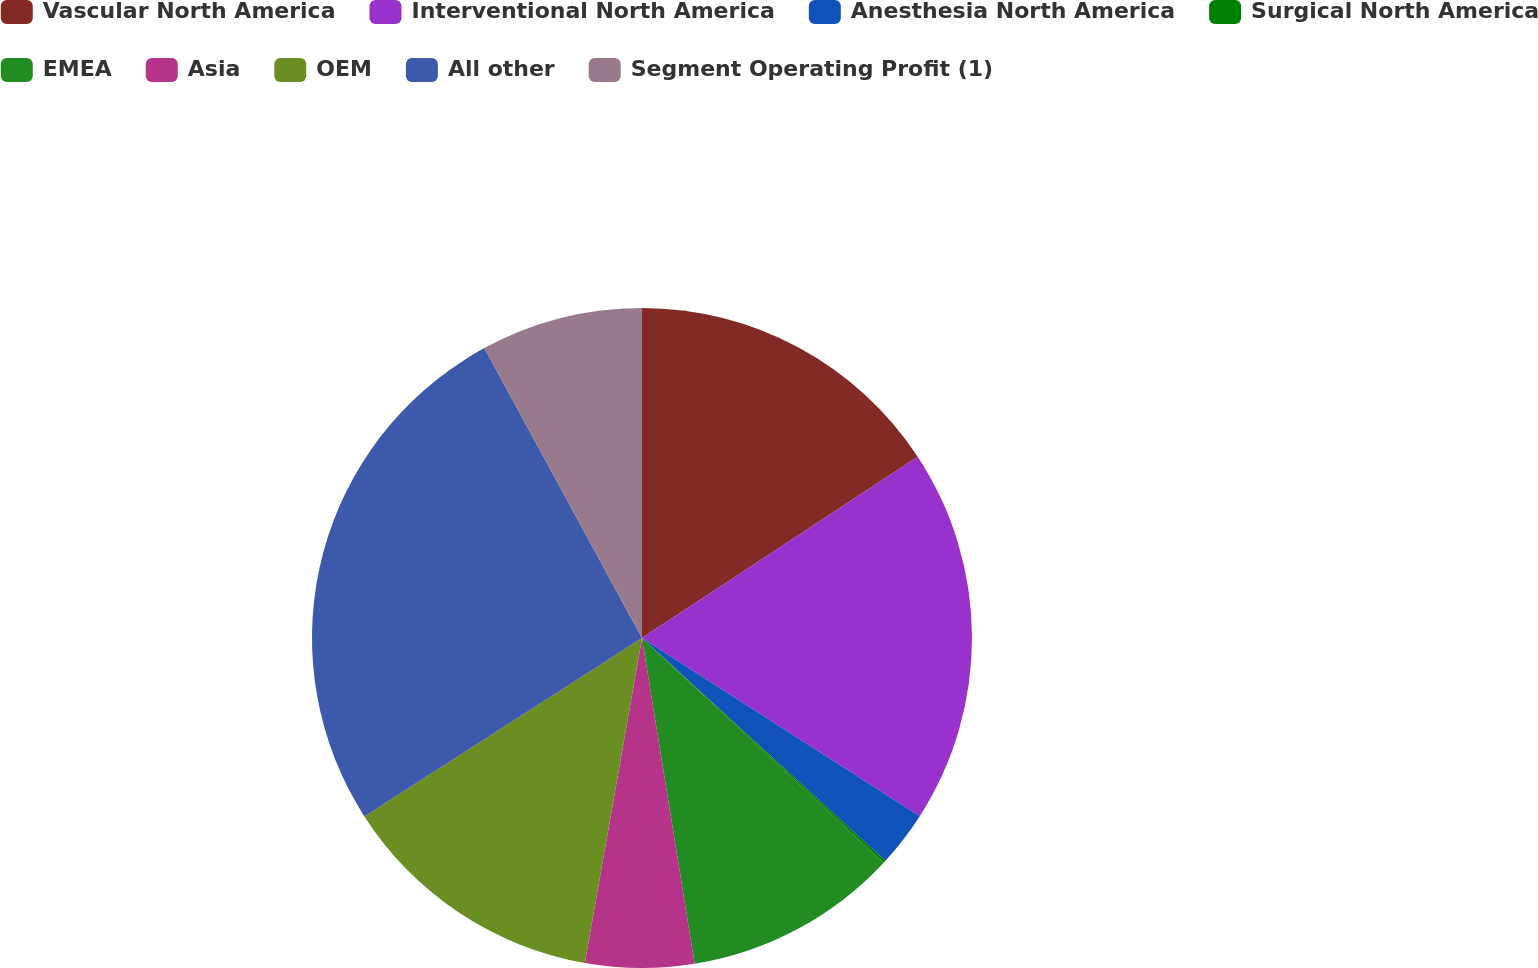Convert chart. <chart><loc_0><loc_0><loc_500><loc_500><pie_chart><fcel>Vascular North America<fcel>Interventional North America<fcel>Anesthesia North America<fcel>Surgical North America<fcel>EMEA<fcel>Asia<fcel>OEM<fcel>All other<fcel>Segment Operating Profit (1)<nl><fcel>15.74%<fcel>18.34%<fcel>2.72%<fcel>0.12%<fcel>10.53%<fcel>5.32%<fcel>13.14%<fcel>26.16%<fcel>7.93%<nl></chart> 